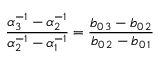Convert formula to latex. <formula><loc_0><loc_0><loc_500><loc_500>{ \frac { \alpha _ { 3 } ^ { - 1 } - \alpha _ { 2 } ^ { - 1 } } { \alpha _ { 2 } ^ { - 1 } - \alpha _ { 1 } ^ { - 1 } } } = { \frac { b _ { 0 \, 3 } - b _ { 0 \, 2 } } { b _ { 0 \, 2 } - b _ { 0 \, 1 } } }</formula> 